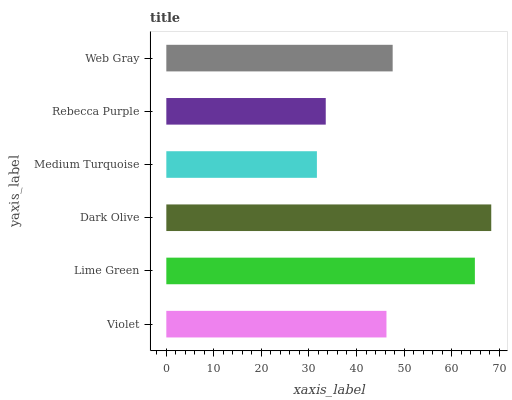Is Medium Turquoise the minimum?
Answer yes or no. Yes. Is Dark Olive the maximum?
Answer yes or no. Yes. Is Lime Green the minimum?
Answer yes or no. No. Is Lime Green the maximum?
Answer yes or no. No. Is Lime Green greater than Violet?
Answer yes or no. Yes. Is Violet less than Lime Green?
Answer yes or no. Yes. Is Violet greater than Lime Green?
Answer yes or no. No. Is Lime Green less than Violet?
Answer yes or no. No. Is Web Gray the high median?
Answer yes or no. Yes. Is Violet the low median?
Answer yes or no. Yes. Is Dark Olive the high median?
Answer yes or no. No. Is Dark Olive the low median?
Answer yes or no. No. 